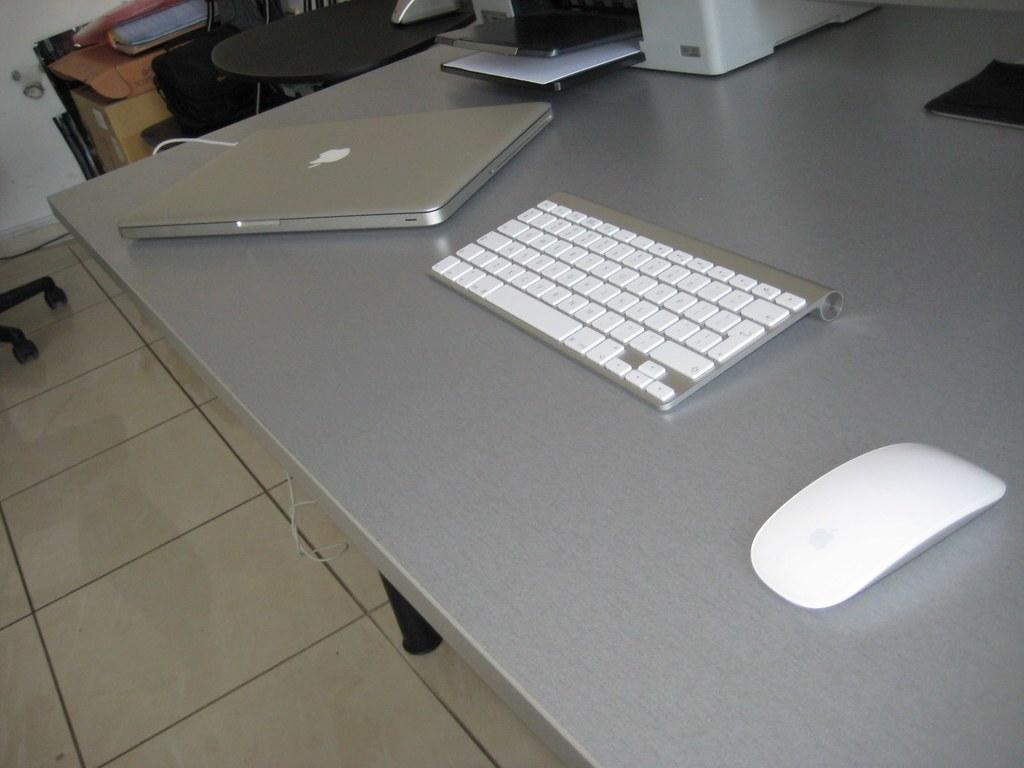In one or two sentences, can you explain what this image depicts? There is a laptop,keyboard,mouse and printer on the table. In the background there are tables and chairs. 